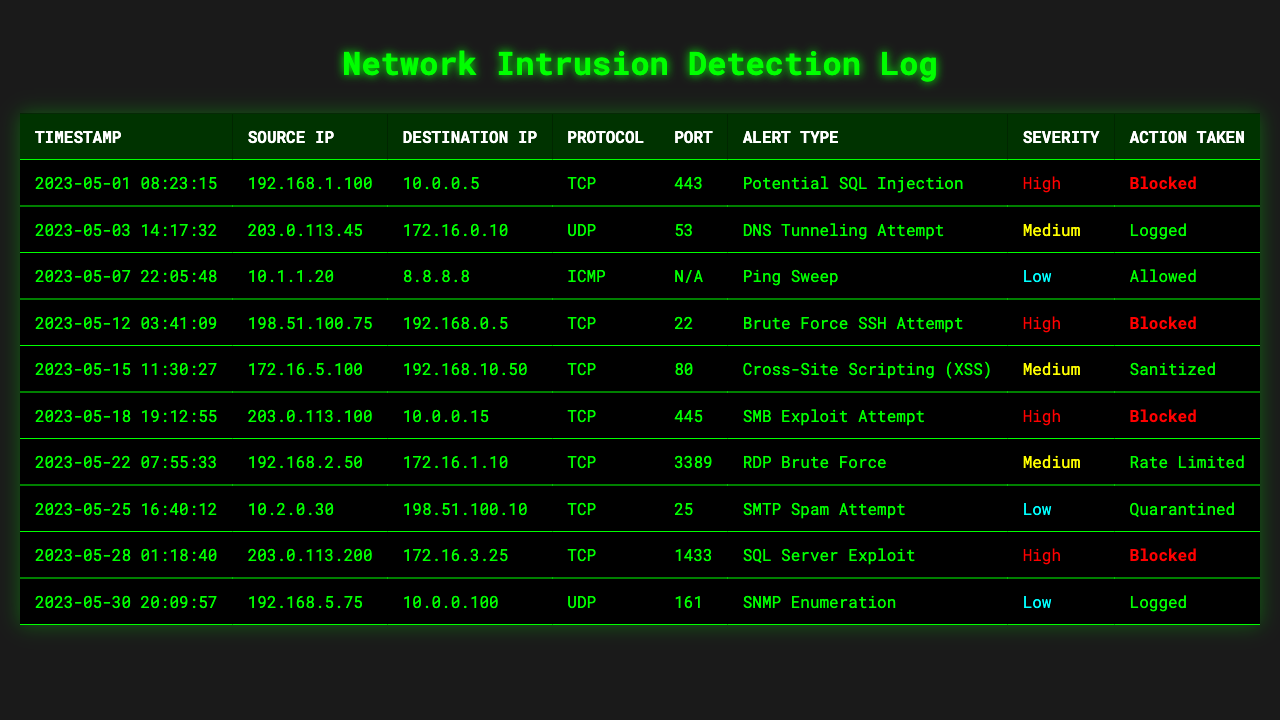What is the highest severity alert type recorded in the log? By examining the 'Severity' column, "High" appears multiple times, indicating that there are alerts with this highest severity level. The alert types associated with "High" severity are: Potential SQL Injection, Brute Force SSH Attempt, SMB Exploit Attempt, and SQL Server Exploit.
Answer: Potential SQL Injection How many log entries were blocked as a result of detected incidents? To determine the number of blocked entries, we can look through the 'Action Taken' column and count the occurrences of "Blocked". There are 4 entries where action taken was "Blocked".
Answer: 4 Which source IP had the earliest timestamp in the logs? The timestamps in the log can be sorted in ascending order to find the earliest entry. The earliest timestamp is "2023-05-01 08:23:15" from the source IP "192.168.1.100".
Answer: 192.168.1.100 How many entries involved UDP protocol? By scanning through the 'Protocol' column we can count how many times "UDP" appears. There are 2 entries that involved UDP.
Answer: 2 What action was taken for the DNS Tunneling Attempt? Looking at the specific row for the alert "DNS Tunneling Attempt" in the 'Alert Type' column, we see that the action taken was "Logged".
Answer: Logged Is there any entry recorded for the "Cross-Site Scripting (XSS)" alert type? Yes, by locating the row with "Cross-Site Scripting (XSS)" in the 'Alert Type' column, we confirm that such an entry exists.
Answer: Yes What is the average severity level of the alerts in the log data? Each severity level can be assigned a numerical value: High=3, Medium=2, Low=1. We calculate the average by summing the severity values (4 High, 4 Medium, and 3 Low = (4*3 + 4*2 + 3*1) / 11 = 2.09), rounding this indicates the average severity level is Medium.
Answer: Medium Which alert type has the maximum occurrence in the log data? By analyzing the 'Alert Type' column and counting the frequency of each type, we discover that there is no 'alert type' that appears more than once across the data. Thus, all alert types have a maximum occurrence of 1.
Answer: None What percentage of actions taken were blocked? The total number of log entries is 10. Since we established earlier that 4 entries were blocked, the percentage is calculated as (4/10) * 100 = 40%.
Answer: 40% How many different destination IPs are recorded in the log data? By reviewing the 'Destination IP' column, we check for unique entries. The distinct destination IPs present total 9.
Answer: 9 